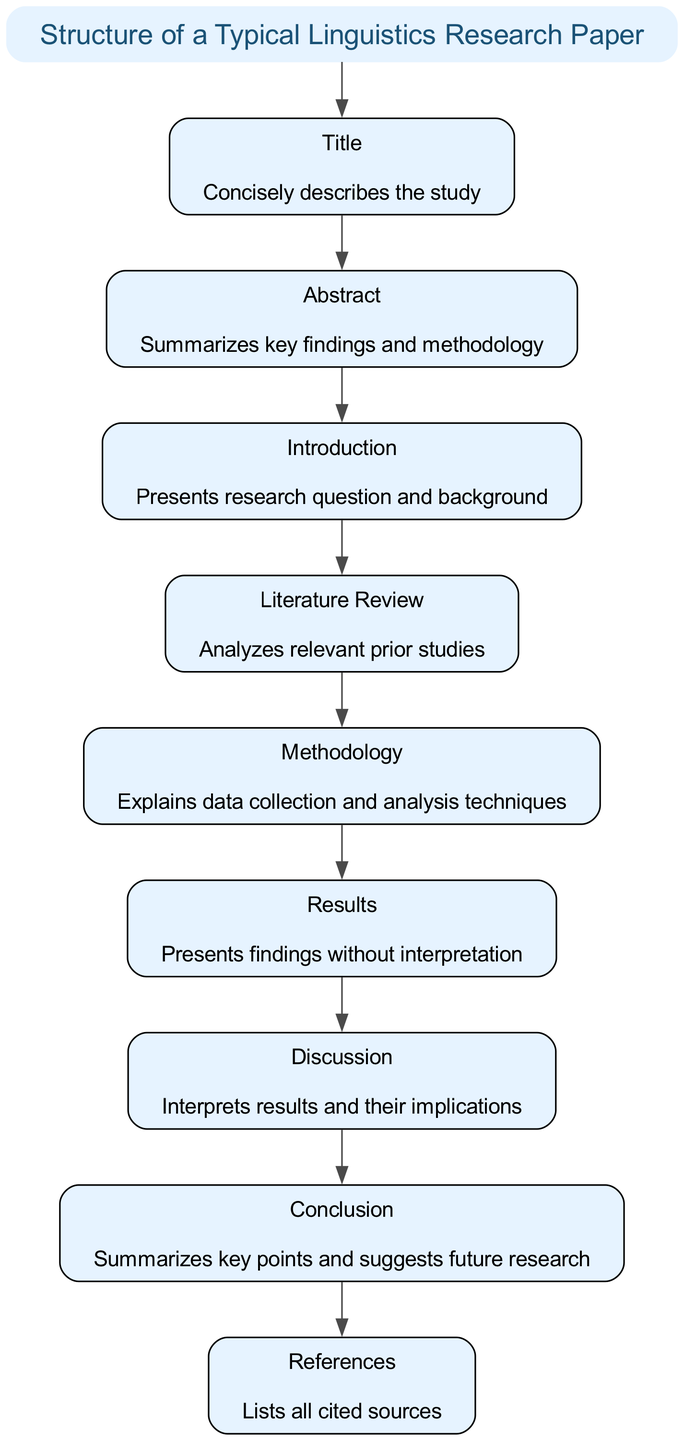What is the title of the diagram? The title of the diagram is clearly labeled at the top and reads: "Structure of a Typical Linguistics Research Paper."
Answer: Structure of a Typical Linguistics Research Paper How many sections are in the research paper structure? The diagram includes nine sections, which are explicitly labeled below the title.
Answer: 9 What is the purpose of the Discussion section? The Discussion section is labeled in the diagram and states that its purpose is "Interprets results and their implications."
Answer: Interprets results and their implications Which section follows the Methodology? According to the flow of the sections in the diagram, the section that follows Methodology is Results, as indicated by the connections between nodes.
Answer: Results What does the Abstract summarize? The Abstract, as noted in the diagram, summarizes key findings and methodology, providing insight into its specific purpose.
Answer: Key findings and methodology How many edges connect the sections of the paper? Each section is connected by a directed edge in a linear order, indicating that there are eight edges (since there are nine sections).
Answer: 8 Which section introduces the research question? The Introduction section is described in the diagram as the part that "Presents research question and background," making it clear that this section covers the research question.
Answer: Introduction What is the final section of the research paper according to the diagram? The last section is labeled as References, which follows the Conclusion section and signifies where all cited sources are listed.
Answer: References What is the immediate purpose of the Literature Review? The diagram specifies that the Literature Review analyzes relevant prior studies, defining its immediate purpose in the research structure.
Answer: Analyzes relevant prior studies 